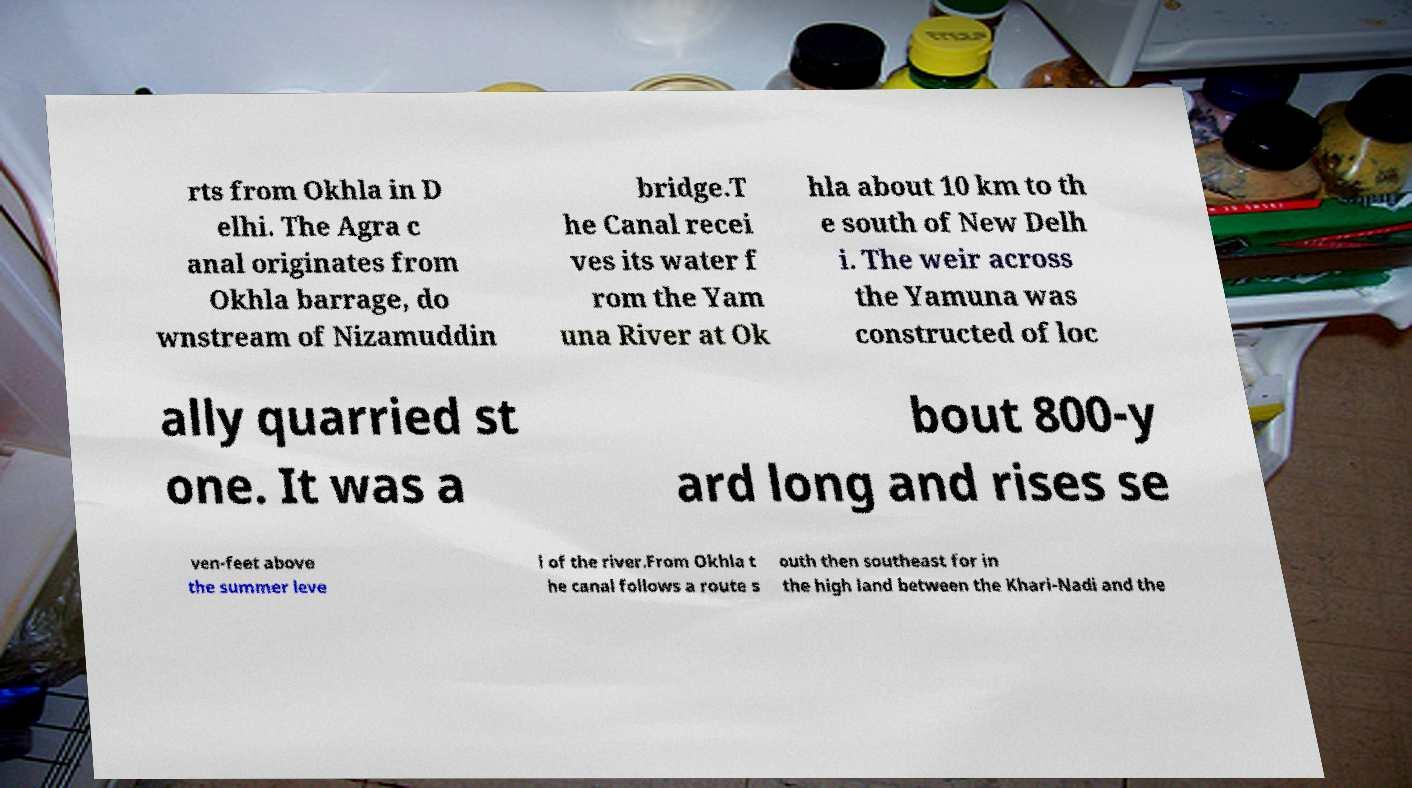There's text embedded in this image that I need extracted. Can you transcribe it verbatim? rts from Okhla in D elhi. The Agra c anal originates from Okhla barrage, do wnstream of Nizamuddin bridge.T he Canal recei ves its water f rom the Yam una River at Ok hla about 10 km to th e south of New Delh i. The weir across the Yamuna was constructed of loc ally quarried st one. It was a bout 800-y ard long and rises se ven-feet above the summer leve l of the river.From Okhla t he canal follows a route s outh then southeast for in the high land between the Khari-Nadi and the 